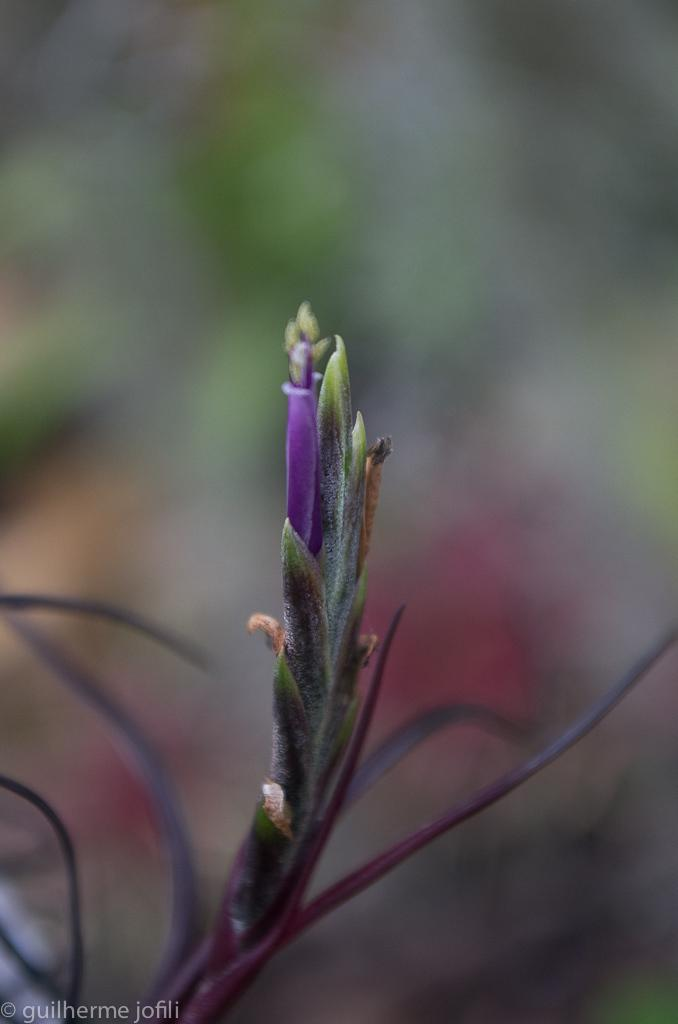What is the main subject of the image? There is a plant in the image. What color is the flower on the plant? The flower on the plant has a violet color. Can you describe the background of the image? The background of the image is blurred. What type of silver object can be seen in the image? There is no silver object present in the image; it features a plant with a violet flower and a blurred background. What need does the plant have in the image? The image does not provide information about the plant's needs, such as water or sunlight. 